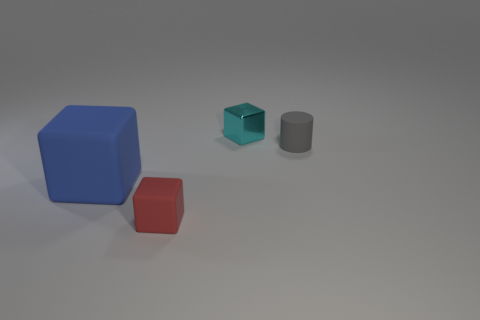Can you describe the lighting in the image? The image is lit from above with soft lighting that casts gentle shadows on the ground to the right of the objects, suggesting a single diffused light source. 